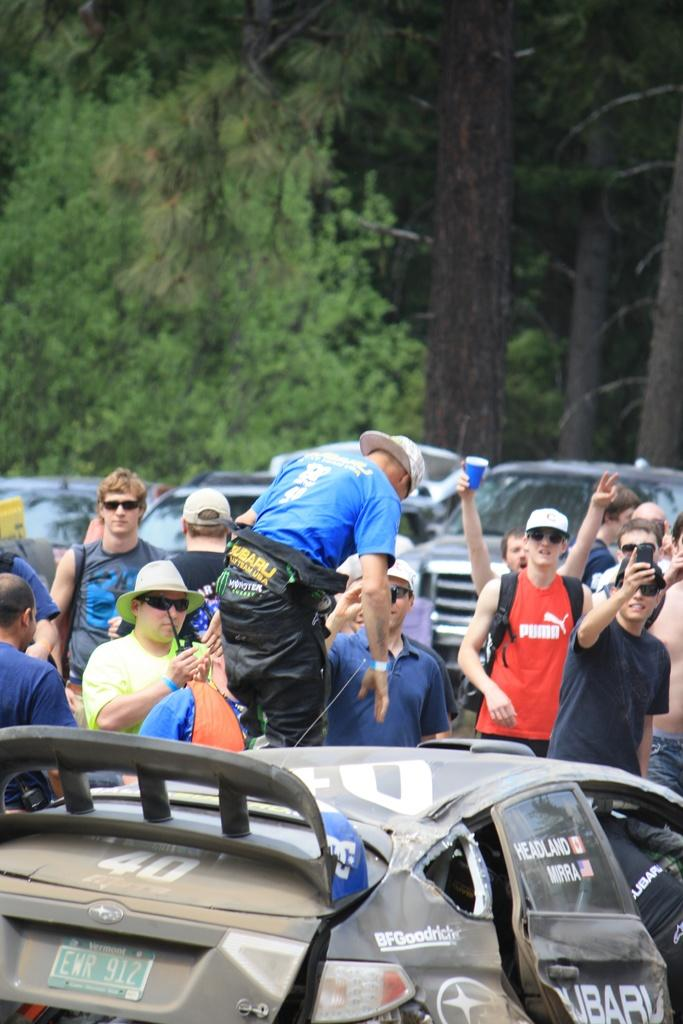What is the main subject in the front of the image? There is a car in the front of the image. What are the people near the car doing? The people standing near the car are taking pictures. How many cars can be seen in the image? There are many cars behind the people in the image. What can be seen in the background of the image? There are trees in the background of the image. What type of riddle can be solved by looking at the car in the image? There is no riddle present in the image, and therefore no such riddle can be solved by looking at the car. 